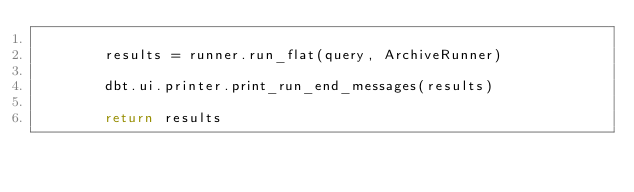<code> <loc_0><loc_0><loc_500><loc_500><_Python_>
        results = runner.run_flat(query, ArchiveRunner)

        dbt.ui.printer.print_run_end_messages(results)

        return results
</code> 